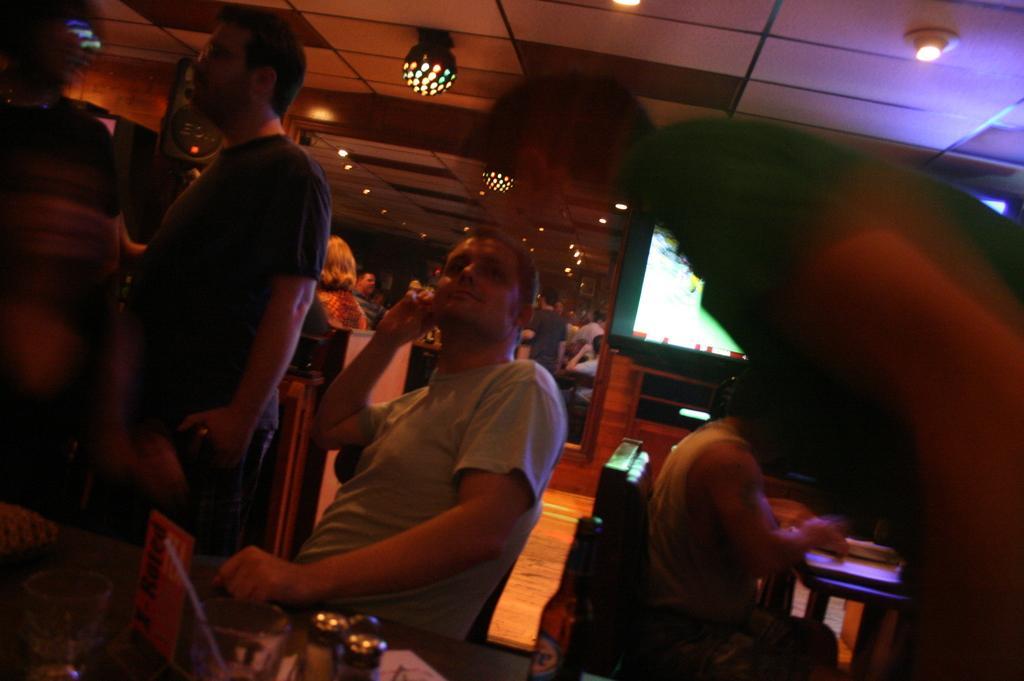Can you describe this image briefly? In this image we can see group of people standing, some people are sitting on chairs. In the bottom left corner of the image we can see some glasses, bottles, board with some text placed on the table. In the background, we can see a screen and a speaker box. At the top of the image we can see some lights on the roof. 